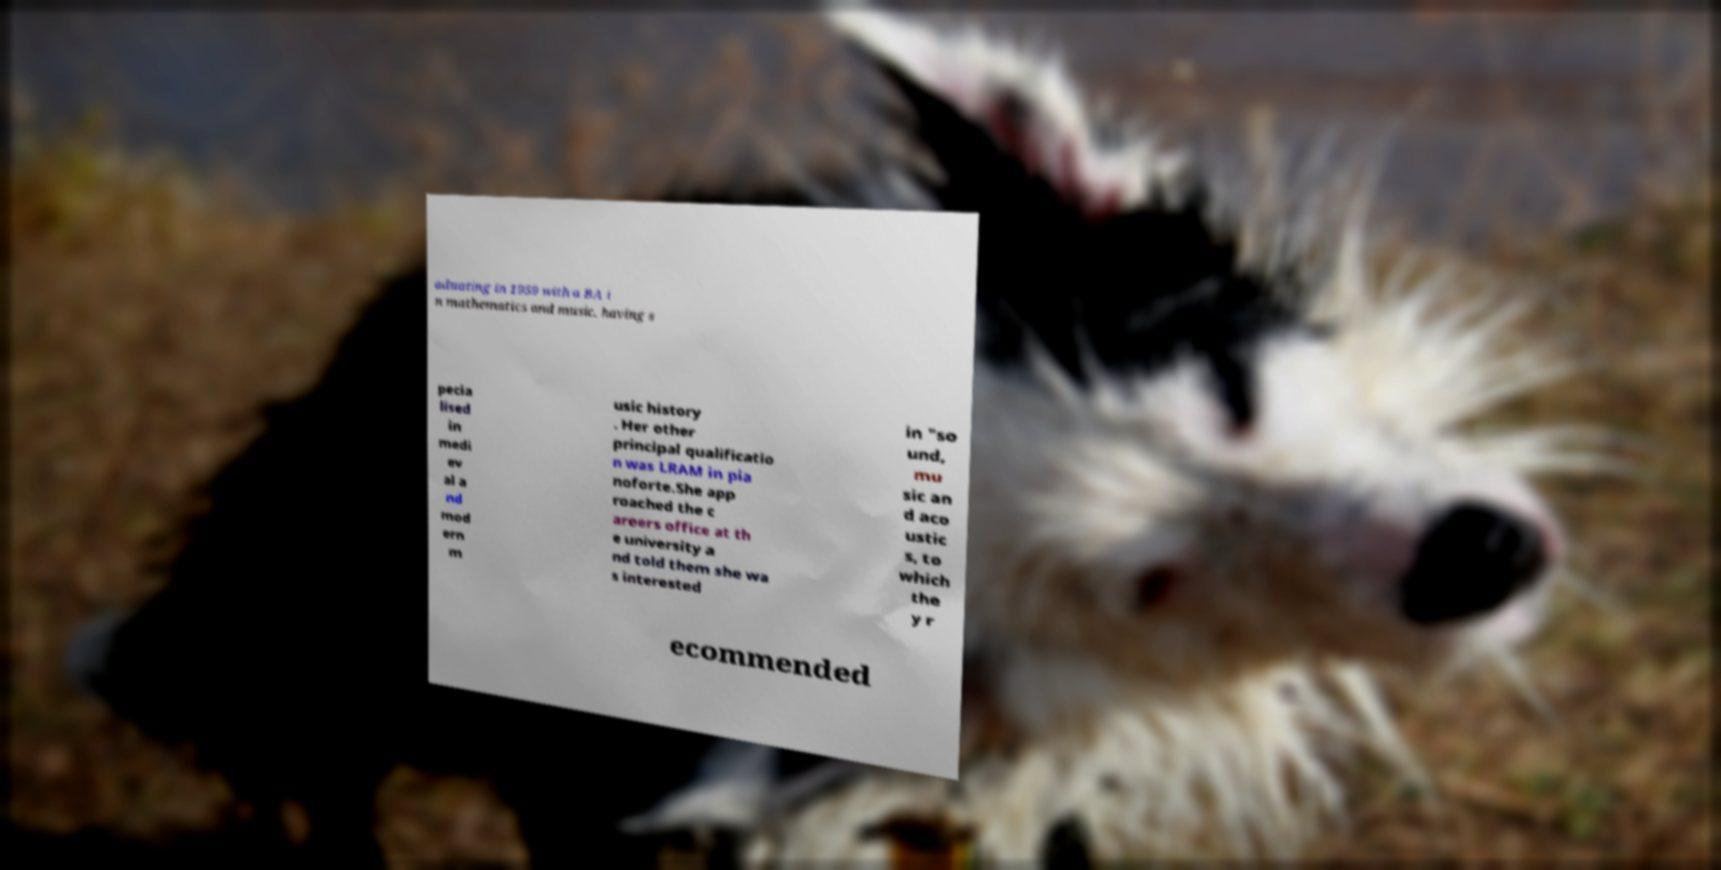Can you read and provide the text displayed in the image?This photo seems to have some interesting text. Can you extract and type it out for me? aduating in 1959 with a BA i n mathematics and music, having s pecia lised in medi ev al a nd mod ern m usic history . Her other principal qualificatio n was LRAM in pia noforte.She app roached the c areers office at th e university a nd told them she wa s interested in "so und, mu sic an d aco ustic s, to which the y r ecommended 